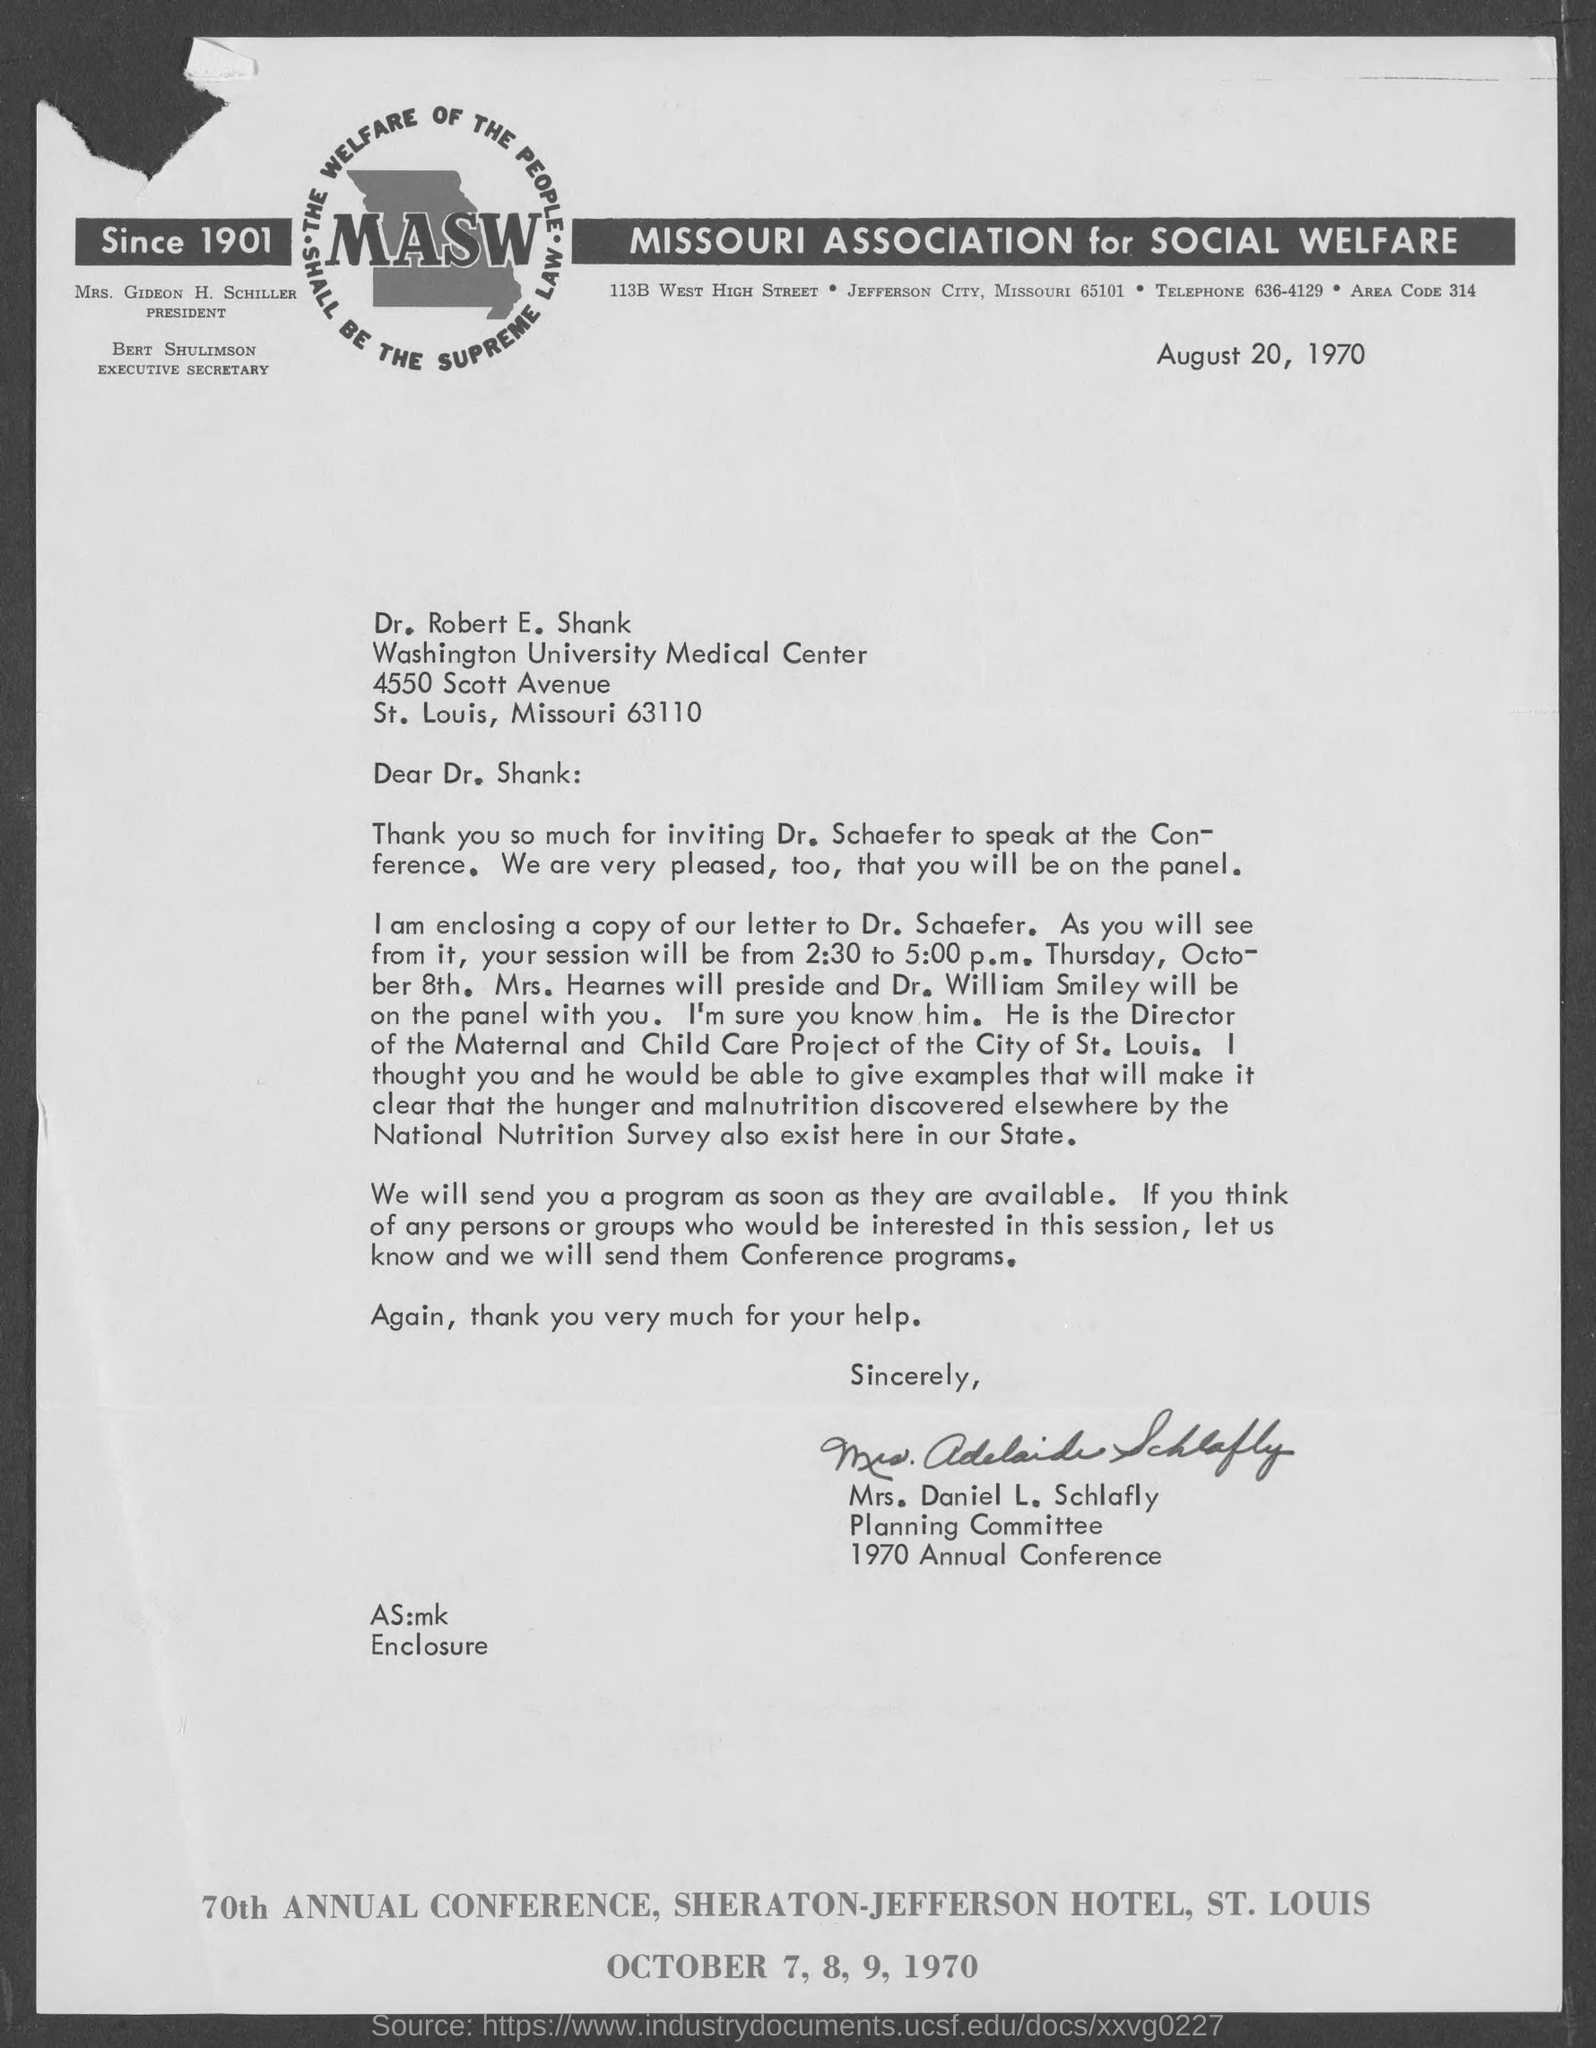Where is the annual conference going to be held?
Provide a succinct answer. SHERATON-JEFFERSON HOTEL, ST. LOUIS. When is the conference going to be held?
Provide a succinct answer. October 7, 8, 9, 1970. When is the document dated?
Your answer should be very brief. August 20, 1970. Who has been invited to speak at the Conference?
Keep it short and to the point. Dr. Schaefer. Who will preside over the session on October 8th?
Offer a very short reply. Mrs. Hearnes. Who is the sender?
Provide a short and direct response. Mrs. Daniel L. Schlafly. 